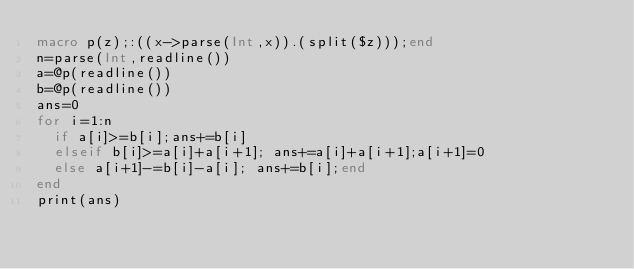<code> <loc_0><loc_0><loc_500><loc_500><_Julia_>macro p(z);:((x->parse(Int,x)).(split($z)));end
n=parse(Int,readline())
a=@p(readline())
b=@p(readline())
ans=0
for i=1:n
  if a[i]>=b[i];ans+=b[i]
  elseif b[i]>=a[i]+a[i+1]; ans+=a[i]+a[i+1];a[i+1]=0
  else a[i+1]-=b[i]-a[i]; ans+=b[i];end
end
print(ans)</code> 